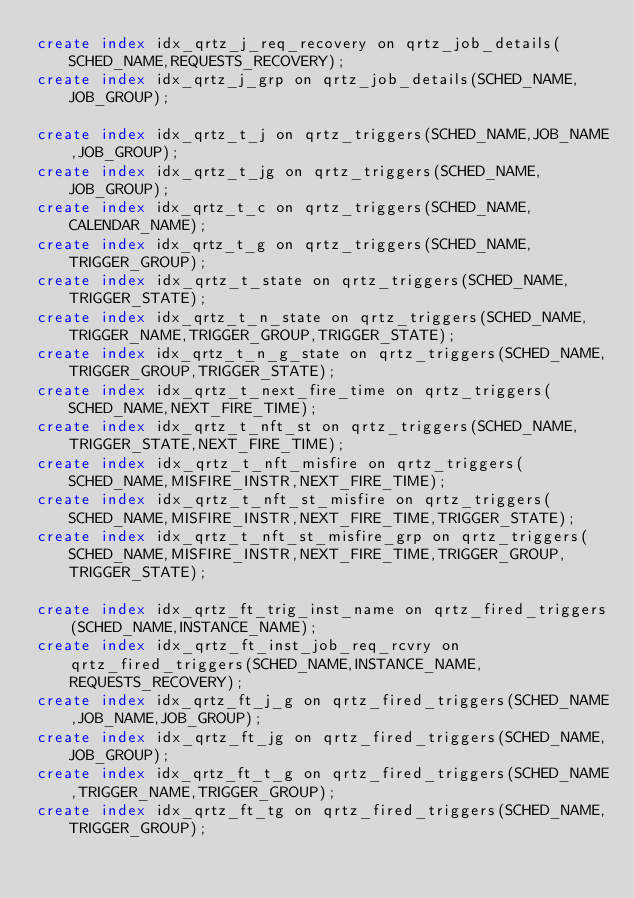Convert code to text. <code><loc_0><loc_0><loc_500><loc_500><_SQL_>create index idx_qrtz_j_req_recovery on qrtz_job_details(SCHED_NAME,REQUESTS_RECOVERY);
create index idx_qrtz_j_grp on qrtz_job_details(SCHED_NAME,JOB_GROUP);

create index idx_qrtz_t_j on qrtz_triggers(SCHED_NAME,JOB_NAME,JOB_GROUP);
create index idx_qrtz_t_jg on qrtz_triggers(SCHED_NAME,JOB_GROUP);
create index idx_qrtz_t_c on qrtz_triggers(SCHED_NAME,CALENDAR_NAME);
create index idx_qrtz_t_g on qrtz_triggers(SCHED_NAME,TRIGGER_GROUP);
create index idx_qrtz_t_state on qrtz_triggers(SCHED_NAME,TRIGGER_STATE);
create index idx_qrtz_t_n_state on qrtz_triggers(SCHED_NAME,TRIGGER_NAME,TRIGGER_GROUP,TRIGGER_STATE);
create index idx_qrtz_t_n_g_state on qrtz_triggers(SCHED_NAME,TRIGGER_GROUP,TRIGGER_STATE);
create index idx_qrtz_t_next_fire_time on qrtz_triggers(SCHED_NAME,NEXT_FIRE_TIME);
create index idx_qrtz_t_nft_st on qrtz_triggers(SCHED_NAME,TRIGGER_STATE,NEXT_FIRE_TIME);
create index idx_qrtz_t_nft_misfire on qrtz_triggers(SCHED_NAME,MISFIRE_INSTR,NEXT_FIRE_TIME);
create index idx_qrtz_t_nft_st_misfire on qrtz_triggers(SCHED_NAME,MISFIRE_INSTR,NEXT_FIRE_TIME,TRIGGER_STATE);
create index idx_qrtz_t_nft_st_misfire_grp on qrtz_triggers(SCHED_NAME,MISFIRE_INSTR,NEXT_FIRE_TIME,TRIGGER_GROUP,TRIGGER_STATE);

create index idx_qrtz_ft_trig_inst_name on qrtz_fired_triggers(SCHED_NAME,INSTANCE_NAME);
create index idx_qrtz_ft_inst_job_req_rcvry on qrtz_fired_triggers(SCHED_NAME,INSTANCE_NAME,REQUESTS_RECOVERY);
create index idx_qrtz_ft_j_g on qrtz_fired_triggers(SCHED_NAME,JOB_NAME,JOB_GROUP);
create index idx_qrtz_ft_jg on qrtz_fired_triggers(SCHED_NAME,JOB_GROUP);
create index idx_qrtz_ft_t_g on qrtz_fired_triggers(SCHED_NAME,TRIGGER_NAME,TRIGGER_GROUP);
create index idx_qrtz_ft_tg on qrtz_fired_triggers(SCHED_NAME,TRIGGER_GROUP);
</code> 